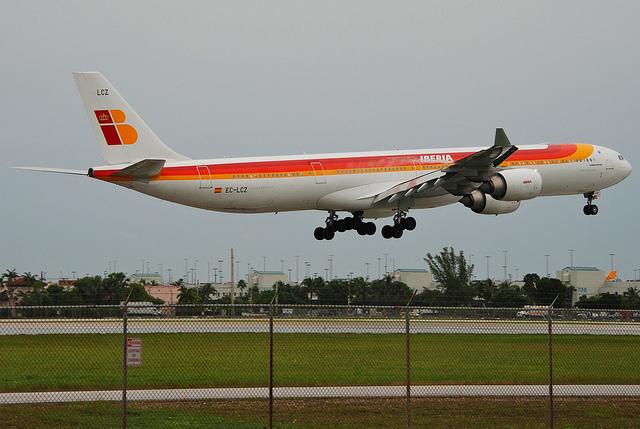What color are the stripes?
Write a very short answer. Red and orange. Is the grass well cut?
Write a very short answer. Yes. Is the plane ascending?
Quick response, please. No. 